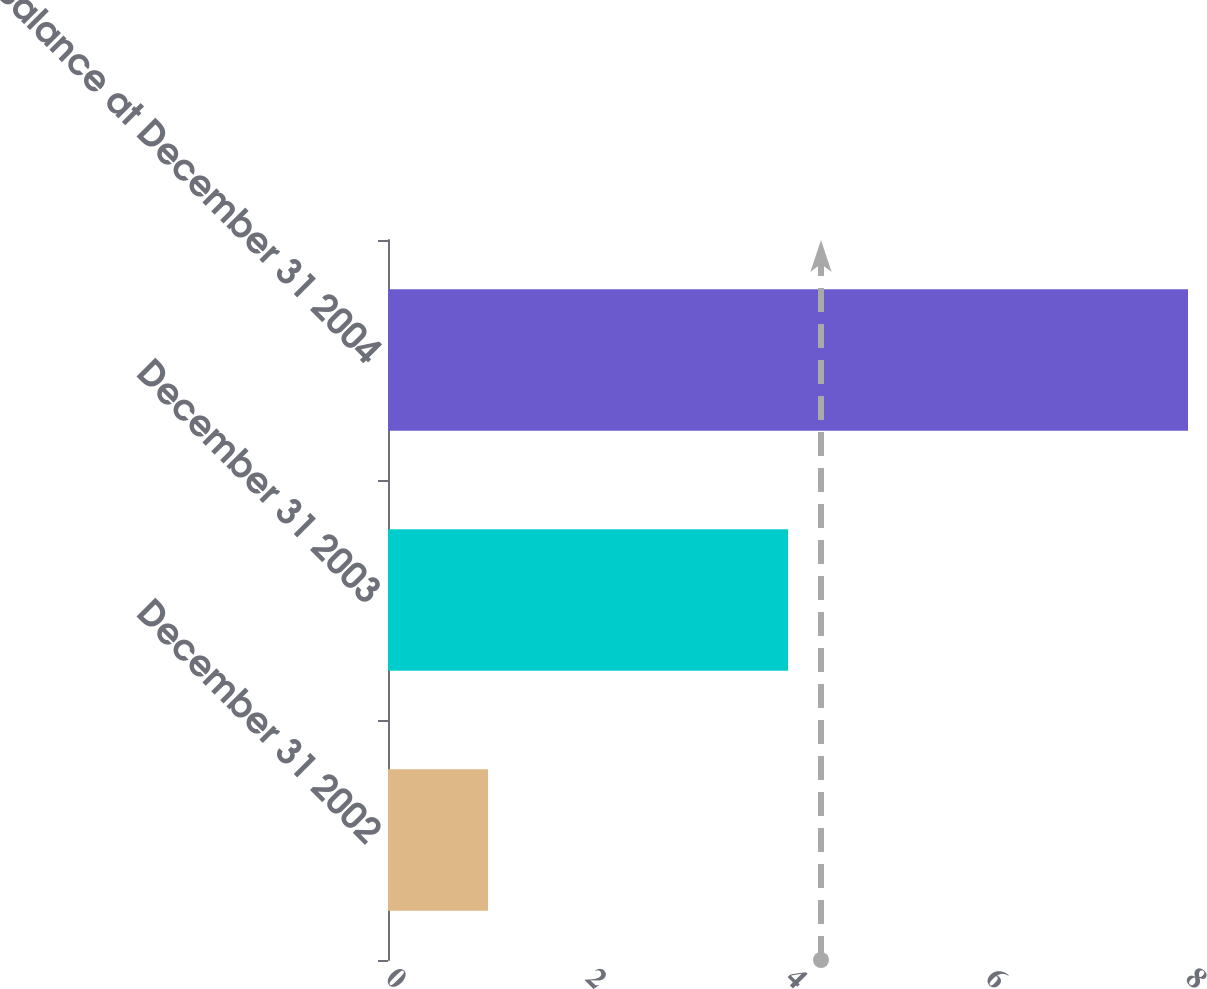<chart> <loc_0><loc_0><loc_500><loc_500><bar_chart><fcel>December 31 2002<fcel>December 31 2003<fcel>Balance at December 31 2004<nl><fcel>1<fcel>4<fcel>8<nl></chart> 